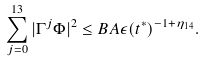Convert formula to latex. <formula><loc_0><loc_0><loc_500><loc_500>\sum _ { j = 0 } ^ { 1 3 } | \Gamma ^ { j } \Phi | ^ { 2 } \leq B A \epsilon ( t ^ { * } ) ^ { - 1 + \eta _ { 1 4 } } .</formula> 